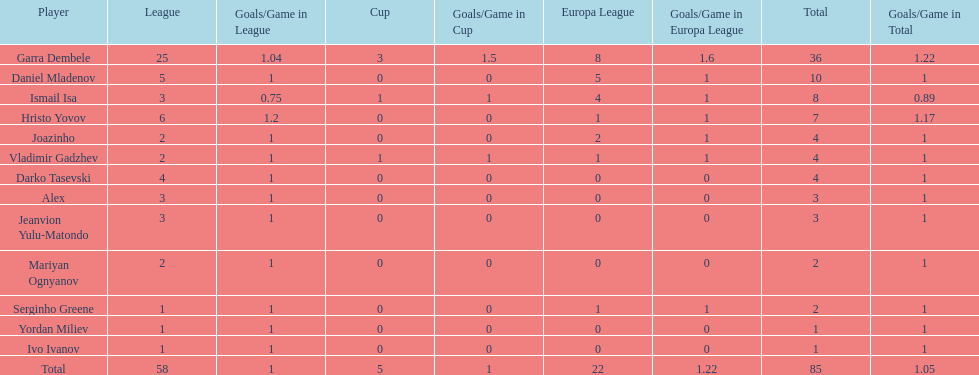How many players had a total of 4? 3. 